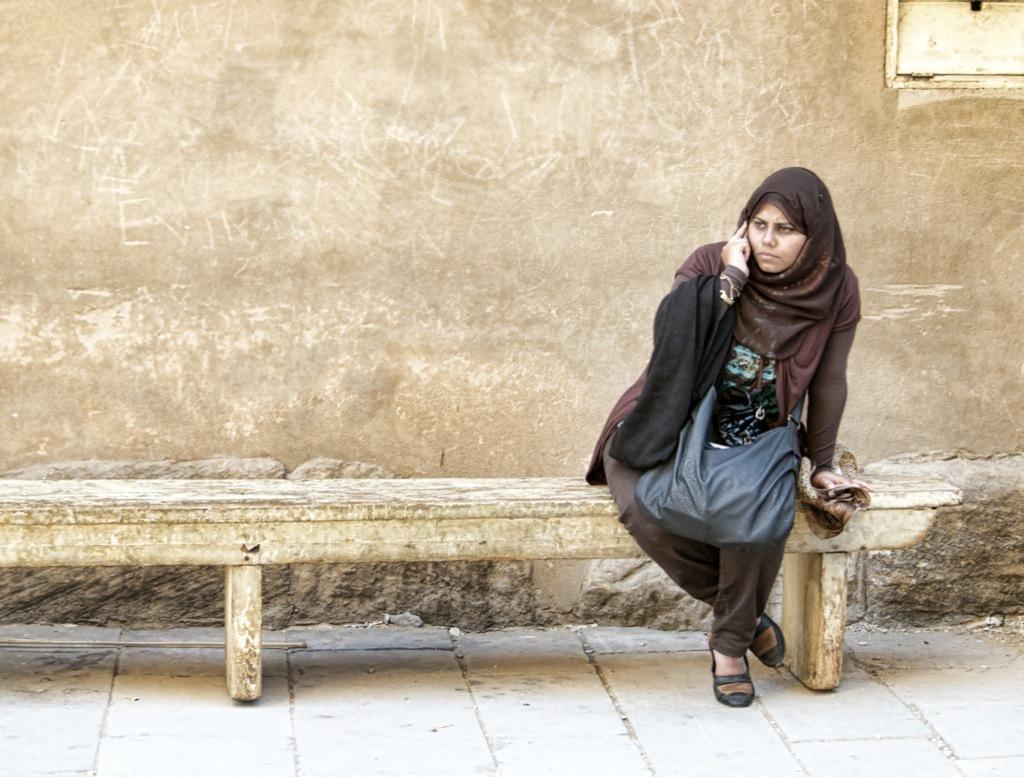Who is present in the image? There is a woman in the image. What is the woman sitting on? The woman is sitting on a wooden bench. What can be seen behind the woman? There is a wall in the image. What is visible at the bottom of the image? The floor is visible at the bottom of the image. Where is the store located in the image? There is no store present in the image. What type of land can be seen in the image? The image does not show any land; it features a woman sitting on a wooden bench with a wall behind her. 